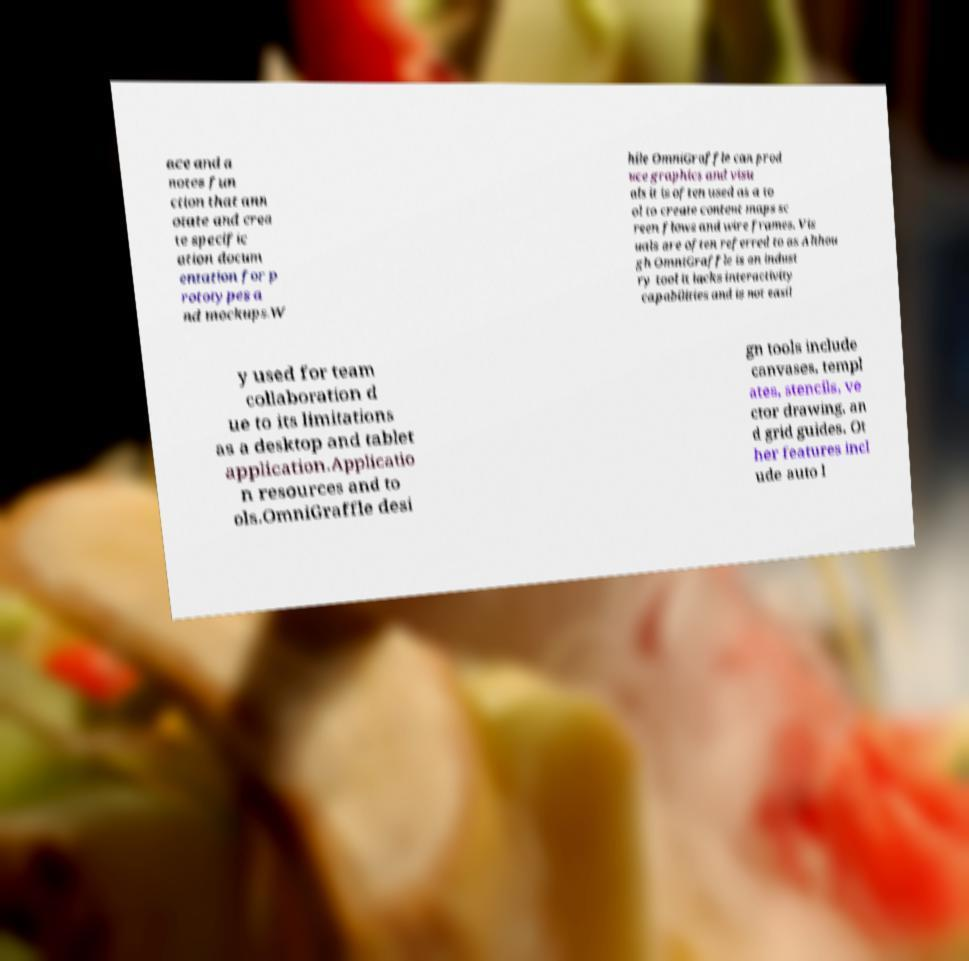Please read and relay the text visible in this image. What does it say? ace and a notes fun ction that ann otate and crea te specific ation docum entation for p rototypes a nd mockups.W hile OmniGraffle can prod uce graphics and visu als it is often used as a to ol to create content maps sc reen flows and wire frames. Vis uals are often referred to as Althou gh OmniGraffle is an indust ry tool it lacks interactivity capabilities and is not easil y used for team collaboration d ue to its limitations as a desktop and tablet application.Applicatio n resources and to ols.OmniGraffle desi gn tools include canvases, templ ates, stencils, ve ctor drawing, an d grid guides. Ot her features incl ude auto l 